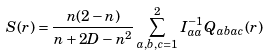Convert formula to latex. <formula><loc_0><loc_0><loc_500><loc_500>S ( r ) = \frac { n ( 2 - n ) } { n + 2 D - n ^ { 2 } } \sum _ { a , b , c = 1 } ^ { 2 } I _ { a a } ^ { - 1 } Q _ { a b a c } ( r )</formula> 